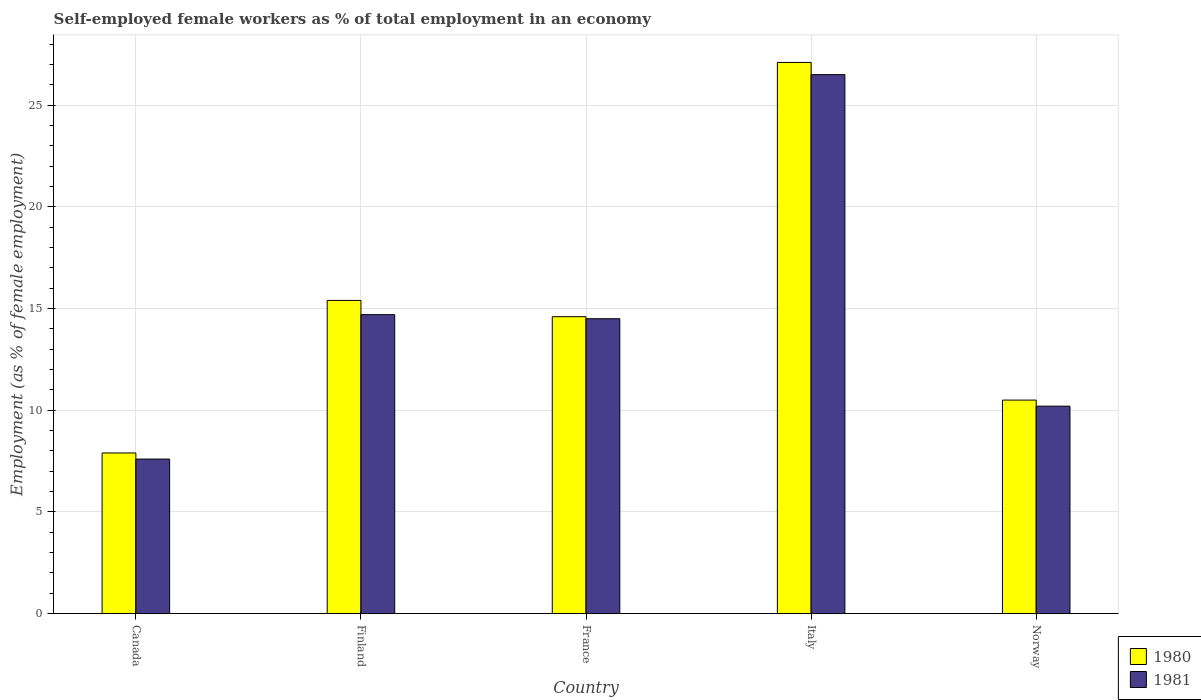How many different coloured bars are there?
Your answer should be very brief. 2. How many groups of bars are there?
Provide a short and direct response. 5. How many bars are there on the 1st tick from the left?
Keep it short and to the point. 2. How many bars are there on the 2nd tick from the right?
Provide a short and direct response. 2. In how many cases, is the number of bars for a given country not equal to the number of legend labels?
Offer a terse response. 0. What is the percentage of self-employed female workers in 1981 in Italy?
Provide a succinct answer. 26.5. Across all countries, what is the maximum percentage of self-employed female workers in 1980?
Ensure brevity in your answer.  27.1. Across all countries, what is the minimum percentage of self-employed female workers in 1981?
Your answer should be compact. 7.6. In which country was the percentage of self-employed female workers in 1981 maximum?
Offer a very short reply. Italy. In which country was the percentage of self-employed female workers in 1980 minimum?
Make the answer very short. Canada. What is the total percentage of self-employed female workers in 1980 in the graph?
Your answer should be compact. 75.5. What is the difference between the percentage of self-employed female workers in 1981 in France and that in Norway?
Ensure brevity in your answer.  4.3. What is the difference between the percentage of self-employed female workers in 1980 in Norway and the percentage of self-employed female workers in 1981 in Finland?
Your answer should be compact. -4.2. What is the average percentage of self-employed female workers in 1981 per country?
Your answer should be very brief. 14.7. What is the difference between the percentage of self-employed female workers of/in 1981 and percentage of self-employed female workers of/in 1980 in France?
Provide a succinct answer. -0.1. In how many countries, is the percentage of self-employed female workers in 1981 greater than 17 %?
Offer a very short reply. 1. What is the ratio of the percentage of self-employed female workers in 1980 in Finland to that in Italy?
Your answer should be very brief. 0.57. Is the percentage of self-employed female workers in 1980 in Finland less than that in France?
Your response must be concise. No. Is the difference between the percentage of self-employed female workers in 1981 in Canada and Norway greater than the difference between the percentage of self-employed female workers in 1980 in Canada and Norway?
Keep it short and to the point. Yes. What is the difference between the highest and the second highest percentage of self-employed female workers in 1981?
Provide a short and direct response. 11.8. What is the difference between the highest and the lowest percentage of self-employed female workers in 1981?
Provide a succinct answer. 18.9. In how many countries, is the percentage of self-employed female workers in 1980 greater than the average percentage of self-employed female workers in 1980 taken over all countries?
Your answer should be very brief. 2. How many bars are there?
Ensure brevity in your answer.  10. Are all the bars in the graph horizontal?
Give a very brief answer. No. What is the difference between two consecutive major ticks on the Y-axis?
Your answer should be very brief. 5. Does the graph contain any zero values?
Make the answer very short. No. Does the graph contain grids?
Ensure brevity in your answer.  Yes. What is the title of the graph?
Your response must be concise. Self-employed female workers as % of total employment in an economy. Does "1993" appear as one of the legend labels in the graph?
Make the answer very short. No. What is the label or title of the Y-axis?
Ensure brevity in your answer.  Employment (as % of female employment). What is the Employment (as % of female employment) in 1980 in Canada?
Your response must be concise. 7.9. What is the Employment (as % of female employment) in 1981 in Canada?
Offer a very short reply. 7.6. What is the Employment (as % of female employment) of 1980 in Finland?
Offer a terse response. 15.4. What is the Employment (as % of female employment) in 1981 in Finland?
Offer a very short reply. 14.7. What is the Employment (as % of female employment) in 1980 in France?
Your response must be concise. 14.6. What is the Employment (as % of female employment) of 1981 in France?
Your response must be concise. 14.5. What is the Employment (as % of female employment) of 1980 in Italy?
Your answer should be very brief. 27.1. What is the Employment (as % of female employment) in 1981 in Italy?
Give a very brief answer. 26.5. What is the Employment (as % of female employment) of 1980 in Norway?
Offer a very short reply. 10.5. What is the Employment (as % of female employment) of 1981 in Norway?
Ensure brevity in your answer.  10.2. Across all countries, what is the maximum Employment (as % of female employment) in 1980?
Offer a very short reply. 27.1. Across all countries, what is the minimum Employment (as % of female employment) of 1980?
Your response must be concise. 7.9. Across all countries, what is the minimum Employment (as % of female employment) in 1981?
Provide a succinct answer. 7.6. What is the total Employment (as % of female employment) in 1980 in the graph?
Your answer should be very brief. 75.5. What is the total Employment (as % of female employment) of 1981 in the graph?
Make the answer very short. 73.5. What is the difference between the Employment (as % of female employment) of 1980 in Canada and that in Finland?
Provide a succinct answer. -7.5. What is the difference between the Employment (as % of female employment) of 1980 in Canada and that in France?
Ensure brevity in your answer.  -6.7. What is the difference between the Employment (as % of female employment) of 1981 in Canada and that in France?
Keep it short and to the point. -6.9. What is the difference between the Employment (as % of female employment) of 1980 in Canada and that in Italy?
Give a very brief answer. -19.2. What is the difference between the Employment (as % of female employment) in 1981 in Canada and that in Italy?
Ensure brevity in your answer.  -18.9. What is the difference between the Employment (as % of female employment) of 1980 in Finland and that in France?
Your answer should be very brief. 0.8. What is the difference between the Employment (as % of female employment) of 1981 in Finland and that in France?
Your response must be concise. 0.2. What is the difference between the Employment (as % of female employment) in 1980 in France and that in Norway?
Give a very brief answer. 4.1. What is the difference between the Employment (as % of female employment) of 1981 in France and that in Norway?
Your answer should be very brief. 4.3. What is the difference between the Employment (as % of female employment) of 1980 in Canada and the Employment (as % of female employment) of 1981 in Finland?
Your answer should be very brief. -6.8. What is the difference between the Employment (as % of female employment) of 1980 in Canada and the Employment (as % of female employment) of 1981 in Italy?
Give a very brief answer. -18.6. What is the difference between the Employment (as % of female employment) of 1980 in Canada and the Employment (as % of female employment) of 1981 in Norway?
Offer a terse response. -2.3. What is the difference between the Employment (as % of female employment) of 1980 in Finland and the Employment (as % of female employment) of 1981 in France?
Give a very brief answer. 0.9. What is the difference between the Employment (as % of female employment) in 1980 in France and the Employment (as % of female employment) in 1981 in Italy?
Make the answer very short. -11.9. What is the difference between the Employment (as % of female employment) in 1980 in Italy and the Employment (as % of female employment) in 1981 in Norway?
Ensure brevity in your answer.  16.9. What is the difference between the Employment (as % of female employment) in 1980 and Employment (as % of female employment) in 1981 in Canada?
Keep it short and to the point. 0.3. What is the difference between the Employment (as % of female employment) in 1980 and Employment (as % of female employment) in 1981 in France?
Your response must be concise. 0.1. What is the ratio of the Employment (as % of female employment) of 1980 in Canada to that in Finland?
Ensure brevity in your answer.  0.51. What is the ratio of the Employment (as % of female employment) of 1981 in Canada to that in Finland?
Provide a short and direct response. 0.52. What is the ratio of the Employment (as % of female employment) in 1980 in Canada to that in France?
Make the answer very short. 0.54. What is the ratio of the Employment (as % of female employment) of 1981 in Canada to that in France?
Give a very brief answer. 0.52. What is the ratio of the Employment (as % of female employment) of 1980 in Canada to that in Italy?
Offer a very short reply. 0.29. What is the ratio of the Employment (as % of female employment) in 1981 in Canada to that in Italy?
Keep it short and to the point. 0.29. What is the ratio of the Employment (as % of female employment) of 1980 in Canada to that in Norway?
Your response must be concise. 0.75. What is the ratio of the Employment (as % of female employment) in 1981 in Canada to that in Norway?
Give a very brief answer. 0.75. What is the ratio of the Employment (as % of female employment) in 1980 in Finland to that in France?
Ensure brevity in your answer.  1.05. What is the ratio of the Employment (as % of female employment) in 1981 in Finland to that in France?
Provide a succinct answer. 1.01. What is the ratio of the Employment (as % of female employment) in 1980 in Finland to that in Italy?
Offer a terse response. 0.57. What is the ratio of the Employment (as % of female employment) in 1981 in Finland to that in Italy?
Your response must be concise. 0.55. What is the ratio of the Employment (as % of female employment) in 1980 in Finland to that in Norway?
Your answer should be very brief. 1.47. What is the ratio of the Employment (as % of female employment) in 1981 in Finland to that in Norway?
Keep it short and to the point. 1.44. What is the ratio of the Employment (as % of female employment) of 1980 in France to that in Italy?
Your response must be concise. 0.54. What is the ratio of the Employment (as % of female employment) of 1981 in France to that in Italy?
Give a very brief answer. 0.55. What is the ratio of the Employment (as % of female employment) of 1980 in France to that in Norway?
Make the answer very short. 1.39. What is the ratio of the Employment (as % of female employment) of 1981 in France to that in Norway?
Offer a terse response. 1.42. What is the ratio of the Employment (as % of female employment) of 1980 in Italy to that in Norway?
Keep it short and to the point. 2.58. What is the ratio of the Employment (as % of female employment) of 1981 in Italy to that in Norway?
Provide a succinct answer. 2.6. 